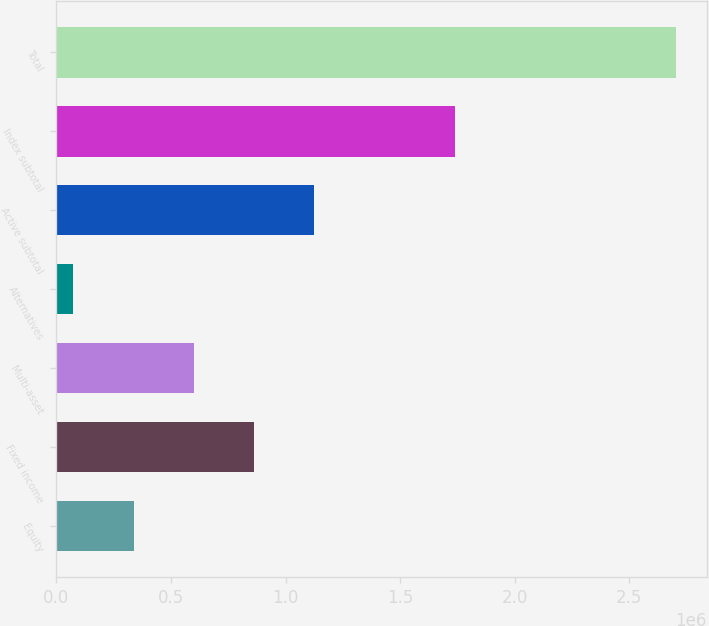Convert chart to OTSL. <chart><loc_0><loc_0><loc_500><loc_500><bar_chart><fcel>Equity<fcel>Fixed income<fcel>Multi-asset<fcel>Alternatives<fcel>Active subtotal<fcel>Index subtotal<fcel>Total<nl><fcel>337610<fcel>862947<fcel>600279<fcel>74941<fcel>1.12562e+06<fcel>1.73878e+06<fcel>2.70163e+06<nl></chart> 